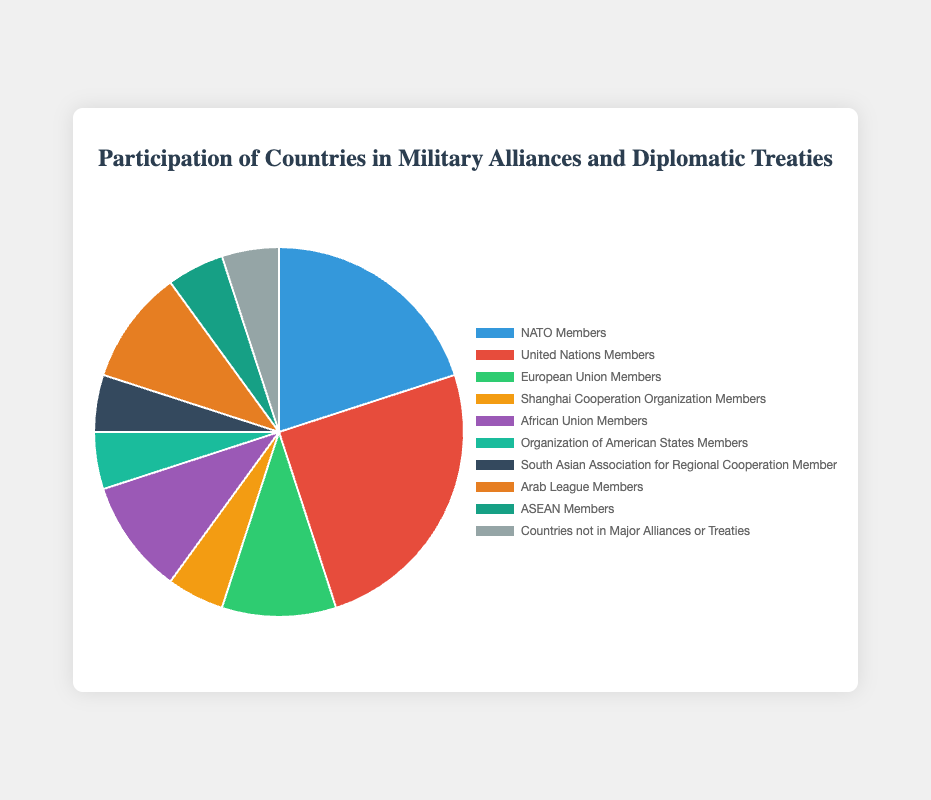What percentage of countries are United Nations Members? Refer to the segment labeled "United Nations Members" in the pie chart, which shows 25%.
Answer: 25% Which alliance or treaty has the smallest participation percentage? Identify the smallest sector in the pie chart, which corresponds to "Shanghai Cooperation Organization Members," with 5%. Other categories like "Organization of American States Members," "South Asian Association for Regional Cooperation Members," "ASEAN Members," and "Countries not in Major Alliances or Treaties" also have the same percentage.
Answer: Shanghai Cooperation Organization Members How many percentage points more are United Nations Members than NATO Members? Find the difference between the percentages of the "United Nations Members" (25%) and "NATO Members" (20%): 25% - 20% = 5%.
Answer: 5% Which entities have an equal percentage of participation, and what is the percentage? Look for sectors that are equal in size. "Shanghai Cooperation Organization Members," "Organization of American States Members," "South Asian Association for Regional Cooperation Members," "ASEAN Members," and "Countries not in Major Alliances or Treaties" all have 5%.
Answer: Shanghai Cooperation Organization Members, Organization of American States Members, South Asian Association for Regional Cooperation Members, ASEAN Members, Countries not in Major Alliances or Treaties, 5% What is the combined percentage of NATO Members and European Union Members? Sum the percentages of "NATO Members" (20%) and "European Union Members" (10%): 20% + 10% = 30%.
Answer: 30% Compare the percentage of European Union Members with African Union Members. Which one has a higher participation percentage and by how much? European Union Members have 10% while African Union Members also have 10%. The difference is 0%.
Answer: Both have the same percentage, 0% How many sectors have a 10% participation rate? Identify the sectors with a 10% participation rate. They belong to "European Union Members," "African Union Members," and "Arab League Members." This makes a total of 3 sectors.
Answer: 3 Which category has a visually striking color and its corresponding percentage? Identify visually striking colors. The "United Nations Members" sector, which is 25%, is in red.
Answer: United Nations Members, 25% If you combine the percentages of the African Union Members, Arab League Members, and ASEAN Members, what is the total? Sum the percentages of these three categories: "African Union Members" (10%) + "Arab League Members" (10%) + "ASEAN Members" (5%) = 25%.
Answer: 25% 